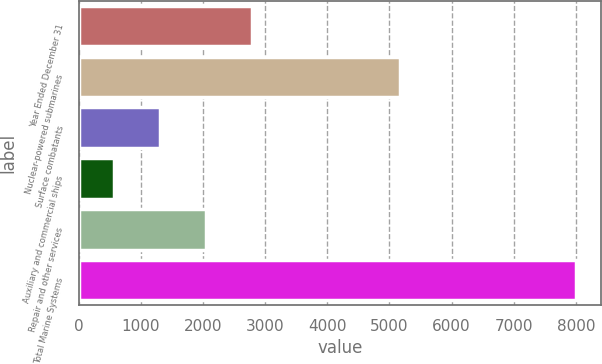<chart> <loc_0><loc_0><loc_500><loc_500><bar_chart><fcel>Year Ended December 31<fcel>Nuclear-powered submarines<fcel>Surface combatants<fcel>Auxiliary and commercial ships<fcel>Repair and other services<fcel>Total Marine Systems<nl><fcel>2796<fcel>5175<fcel>1308<fcel>564<fcel>2052<fcel>8004<nl></chart> 